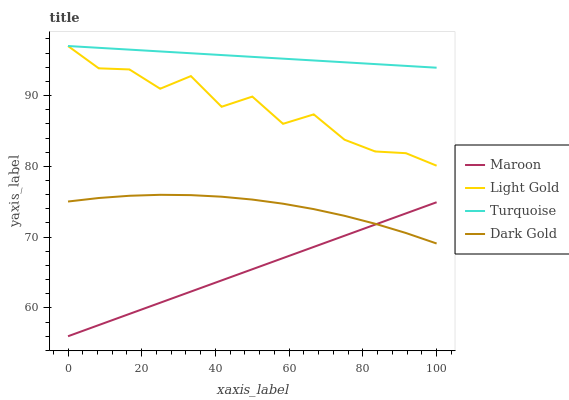Does Maroon have the minimum area under the curve?
Answer yes or no. Yes. Does Turquoise have the maximum area under the curve?
Answer yes or no. Yes. Does Light Gold have the minimum area under the curve?
Answer yes or no. No. Does Light Gold have the maximum area under the curve?
Answer yes or no. No. Is Turquoise the smoothest?
Answer yes or no. Yes. Is Light Gold the roughest?
Answer yes or no. Yes. Is Maroon the smoothest?
Answer yes or no. No. Is Maroon the roughest?
Answer yes or no. No. Does Maroon have the lowest value?
Answer yes or no. Yes. Does Light Gold have the lowest value?
Answer yes or no. No. Does Light Gold have the highest value?
Answer yes or no. Yes. Does Maroon have the highest value?
Answer yes or no. No. Is Maroon less than Light Gold?
Answer yes or no. Yes. Is Turquoise greater than Maroon?
Answer yes or no. Yes. Does Dark Gold intersect Maroon?
Answer yes or no. Yes. Is Dark Gold less than Maroon?
Answer yes or no. No. Is Dark Gold greater than Maroon?
Answer yes or no. No. Does Maroon intersect Light Gold?
Answer yes or no. No. 